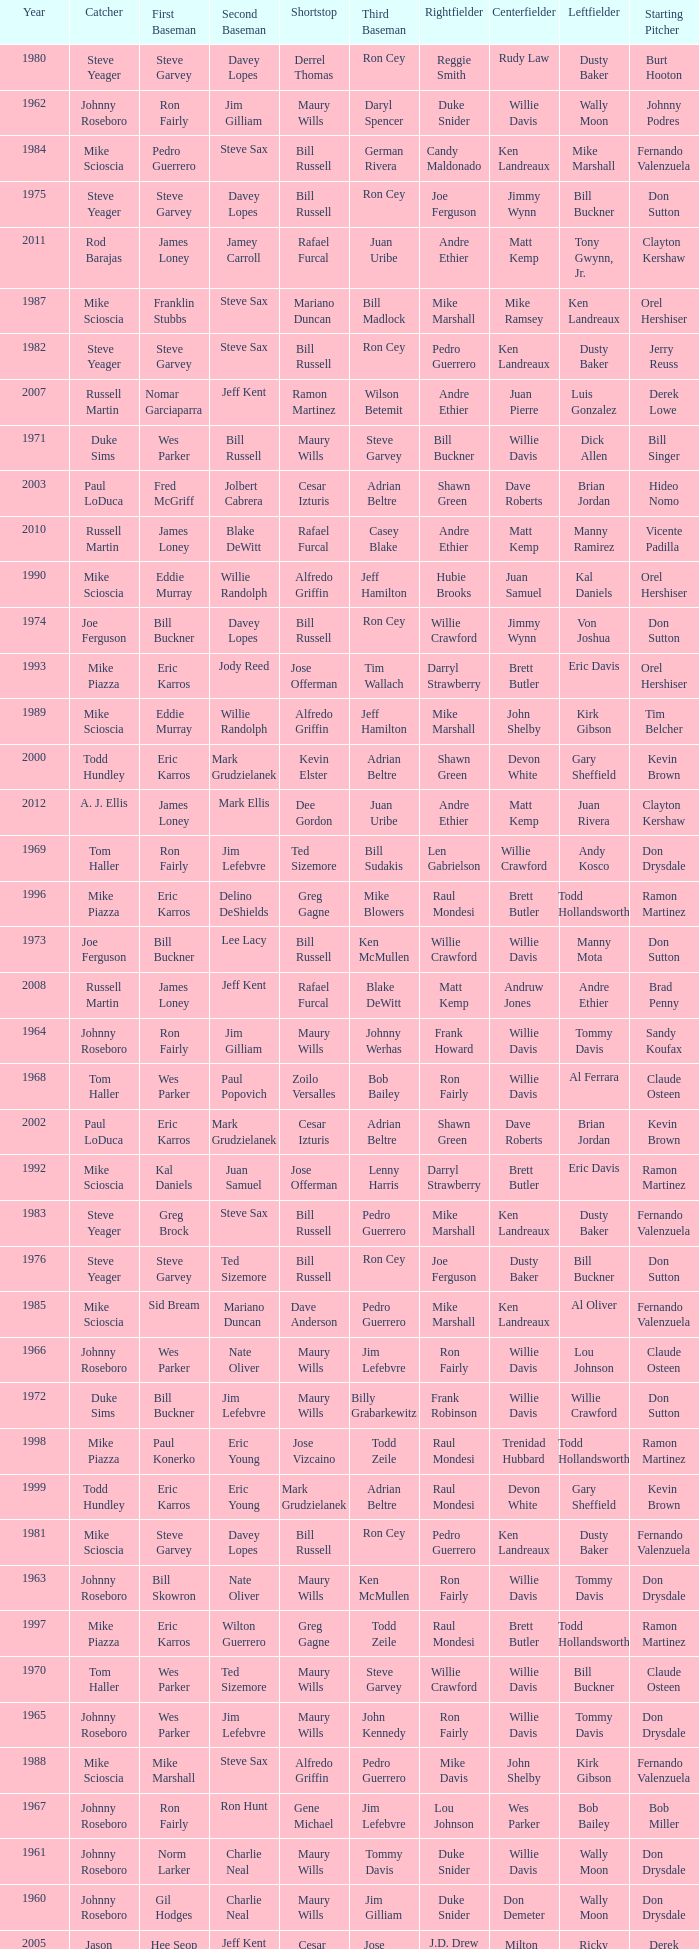Parse the full table. {'header': ['Year', 'Catcher', 'First Baseman', 'Second Baseman', 'Shortstop', 'Third Baseman', 'Rightfielder', 'Centerfielder', 'Leftfielder', 'Starting Pitcher'], 'rows': [['1980', 'Steve Yeager', 'Steve Garvey', 'Davey Lopes', 'Derrel Thomas', 'Ron Cey', 'Reggie Smith', 'Rudy Law', 'Dusty Baker', 'Burt Hooton'], ['1962', 'Johnny Roseboro', 'Ron Fairly', 'Jim Gilliam', 'Maury Wills', 'Daryl Spencer', 'Duke Snider', 'Willie Davis', 'Wally Moon', 'Johnny Podres'], ['1984', 'Mike Scioscia', 'Pedro Guerrero', 'Steve Sax', 'Bill Russell', 'German Rivera', 'Candy Maldonado', 'Ken Landreaux', 'Mike Marshall', 'Fernando Valenzuela'], ['1975', 'Steve Yeager', 'Steve Garvey', 'Davey Lopes', 'Bill Russell', 'Ron Cey', 'Joe Ferguson', 'Jimmy Wynn', 'Bill Buckner', 'Don Sutton'], ['2011', 'Rod Barajas', 'James Loney', 'Jamey Carroll', 'Rafael Furcal', 'Juan Uribe', 'Andre Ethier', 'Matt Kemp', 'Tony Gwynn, Jr.', 'Clayton Kershaw'], ['1987', 'Mike Scioscia', 'Franklin Stubbs', 'Steve Sax', 'Mariano Duncan', 'Bill Madlock', 'Mike Marshall', 'Mike Ramsey', 'Ken Landreaux', 'Orel Hershiser'], ['1982', 'Steve Yeager', 'Steve Garvey', 'Steve Sax', 'Bill Russell', 'Ron Cey', 'Pedro Guerrero', 'Ken Landreaux', 'Dusty Baker', 'Jerry Reuss'], ['2007', 'Russell Martin', 'Nomar Garciaparra', 'Jeff Kent', 'Ramon Martinez', 'Wilson Betemit', 'Andre Ethier', 'Juan Pierre', 'Luis Gonzalez', 'Derek Lowe'], ['1971', 'Duke Sims', 'Wes Parker', 'Bill Russell', 'Maury Wills', 'Steve Garvey', 'Bill Buckner', 'Willie Davis', 'Dick Allen', 'Bill Singer'], ['2003', 'Paul LoDuca', 'Fred McGriff', 'Jolbert Cabrera', 'Cesar Izturis', 'Adrian Beltre', 'Shawn Green', 'Dave Roberts', 'Brian Jordan', 'Hideo Nomo'], ['2010', 'Russell Martin', 'James Loney', 'Blake DeWitt', 'Rafael Furcal', 'Casey Blake', 'Andre Ethier', 'Matt Kemp', 'Manny Ramirez', 'Vicente Padilla'], ['1990', 'Mike Scioscia', 'Eddie Murray', 'Willie Randolph', 'Alfredo Griffin', 'Jeff Hamilton', 'Hubie Brooks', 'Juan Samuel', 'Kal Daniels', 'Orel Hershiser'], ['1974', 'Joe Ferguson', 'Bill Buckner', 'Davey Lopes', 'Bill Russell', 'Ron Cey', 'Willie Crawford', 'Jimmy Wynn', 'Von Joshua', 'Don Sutton'], ['1993', 'Mike Piazza', 'Eric Karros', 'Jody Reed', 'Jose Offerman', 'Tim Wallach', 'Darryl Strawberry', 'Brett Butler', 'Eric Davis', 'Orel Hershiser'], ['1989', 'Mike Scioscia', 'Eddie Murray', 'Willie Randolph', 'Alfredo Griffin', 'Jeff Hamilton', 'Mike Marshall', 'John Shelby', 'Kirk Gibson', 'Tim Belcher'], ['2000', 'Todd Hundley', 'Eric Karros', 'Mark Grudzielanek', 'Kevin Elster', 'Adrian Beltre', 'Shawn Green', 'Devon White', 'Gary Sheffield', 'Kevin Brown'], ['2012', 'A. J. Ellis', 'James Loney', 'Mark Ellis', 'Dee Gordon', 'Juan Uribe', 'Andre Ethier', 'Matt Kemp', 'Juan Rivera', 'Clayton Kershaw'], ['1969', 'Tom Haller', 'Ron Fairly', 'Jim Lefebvre', 'Ted Sizemore', 'Bill Sudakis', 'Len Gabrielson', 'Willie Crawford', 'Andy Kosco', 'Don Drysdale'], ['1996', 'Mike Piazza', 'Eric Karros', 'Delino DeShields', 'Greg Gagne', 'Mike Blowers', 'Raul Mondesi', 'Brett Butler', 'Todd Hollandsworth', 'Ramon Martinez'], ['1973', 'Joe Ferguson', 'Bill Buckner', 'Lee Lacy', 'Bill Russell', 'Ken McMullen', 'Willie Crawford', 'Willie Davis', 'Manny Mota', 'Don Sutton'], ['2008', 'Russell Martin', 'James Loney', 'Jeff Kent', 'Rafael Furcal', 'Blake DeWitt', 'Matt Kemp', 'Andruw Jones', 'Andre Ethier', 'Brad Penny'], ['1964', 'Johnny Roseboro', 'Ron Fairly', 'Jim Gilliam', 'Maury Wills', 'Johnny Werhas', 'Frank Howard', 'Willie Davis', 'Tommy Davis', 'Sandy Koufax'], ['1968', 'Tom Haller', 'Wes Parker', 'Paul Popovich', 'Zoilo Versalles', 'Bob Bailey', 'Ron Fairly', 'Willie Davis', 'Al Ferrara', 'Claude Osteen'], ['2002', 'Paul LoDuca', 'Eric Karros', 'Mark Grudzielanek', 'Cesar Izturis', 'Adrian Beltre', 'Shawn Green', 'Dave Roberts', 'Brian Jordan', 'Kevin Brown'], ['1992', 'Mike Scioscia', 'Kal Daniels', 'Juan Samuel', 'Jose Offerman', 'Lenny Harris', 'Darryl Strawberry', 'Brett Butler', 'Eric Davis', 'Ramon Martinez'], ['1983', 'Steve Yeager', 'Greg Brock', 'Steve Sax', 'Bill Russell', 'Pedro Guerrero', 'Mike Marshall', 'Ken Landreaux', 'Dusty Baker', 'Fernando Valenzuela'], ['1976', 'Steve Yeager', 'Steve Garvey', 'Ted Sizemore', 'Bill Russell', 'Ron Cey', 'Joe Ferguson', 'Dusty Baker', 'Bill Buckner', 'Don Sutton'], ['1985', 'Mike Scioscia', 'Sid Bream', 'Mariano Duncan', 'Dave Anderson', 'Pedro Guerrero', 'Mike Marshall', 'Ken Landreaux', 'Al Oliver', 'Fernando Valenzuela'], ['1966', 'Johnny Roseboro', 'Wes Parker', 'Nate Oliver', 'Maury Wills', 'Jim Lefebvre', 'Ron Fairly', 'Willie Davis', 'Lou Johnson', 'Claude Osteen'], ['1972', 'Duke Sims', 'Bill Buckner', 'Jim Lefebvre', 'Maury Wills', 'Billy Grabarkewitz', 'Frank Robinson', 'Willie Davis', 'Willie Crawford', 'Don Sutton'], ['1998', 'Mike Piazza', 'Paul Konerko', 'Eric Young', 'Jose Vizcaino', 'Todd Zeile', 'Raul Mondesi', 'Trenidad Hubbard', 'Todd Hollandsworth', 'Ramon Martinez'], ['1999', 'Todd Hundley', 'Eric Karros', 'Eric Young', 'Mark Grudzielanek', 'Adrian Beltre', 'Raul Mondesi', 'Devon White', 'Gary Sheffield', 'Kevin Brown'], ['1981', 'Mike Scioscia', 'Steve Garvey', 'Davey Lopes', 'Bill Russell', 'Ron Cey', 'Pedro Guerrero', 'Ken Landreaux', 'Dusty Baker', 'Fernando Valenzuela'], ['1963', 'Johnny Roseboro', 'Bill Skowron', 'Nate Oliver', 'Maury Wills', 'Ken McMullen', 'Ron Fairly', 'Willie Davis', 'Tommy Davis', 'Don Drysdale'], ['1997', 'Mike Piazza', 'Eric Karros', 'Wilton Guerrero', 'Greg Gagne', 'Todd Zeile', 'Raul Mondesi', 'Brett Butler', 'Todd Hollandsworth', 'Ramon Martinez'], ['1970', 'Tom Haller', 'Wes Parker', 'Ted Sizemore', 'Maury Wills', 'Steve Garvey', 'Willie Crawford', 'Willie Davis', 'Bill Buckner', 'Claude Osteen'], ['1965', 'Johnny Roseboro', 'Wes Parker', 'Jim Lefebvre', 'Maury Wills', 'John Kennedy', 'Ron Fairly', 'Willie Davis', 'Tommy Davis', 'Don Drysdale'], ['1988', 'Mike Scioscia', 'Mike Marshall', 'Steve Sax', 'Alfredo Griffin', 'Pedro Guerrero', 'Mike Davis', 'John Shelby', 'Kirk Gibson', 'Fernando Valenzuela'], ['1967', 'Johnny Roseboro', 'Ron Fairly', 'Ron Hunt', 'Gene Michael', 'Jim Lefebvre', 'Lou Johnson', 'Wes Parker', 'Bob Bailey', 'Bob Miller'], ['1961', 'Johnny Roseboro', 'Norm Larker', 'Charlie Neal', 'Maury Wills', 'Tommy Davis', 'Duke Snider', 'Willie Davis', 'Wally Moon', 'Don Drysdale'], ['1960', 'Johnny Roseboro', 'Gil Hodges', 'Charlie Neal', 'Maury Wills', 'Jim Gilliam', 'Duke Snider', 'Don Demeter', 'Wally Moon', 'Don Drysdale'], ['2005', 'Jason Phillips', 'Hee Seop Choi', 'Jeff Kent', 'Cesar Izturis', 'Jose Valentin', 'J.D. Drew', 'Milton Bradley', 'Ricky Ledee', 'Derek Lowe'], ['2013', 'A. J. Ellis', 'Adrian Gonzalez', 'Mark Ellis', 'Justin Sellers', 'Luis Cruz', 'Andre Ethier', 'Matt Kemp', 'Carl Crawford', 'Clayton Kershaw'], ['1978', 'Steve Yeager', 'Steve Garvey', 'Davey Lopes', 'Bill Russell', 'Ron Cey', 'Reggie Smith', 'Rick Monday', 'Dusty Baker', 'Don Sutton'], ['2001', 'Chad Kreuter', 'Eric Karros', 'Mark Grudzielanek', 'Cesar Izturis', 'Chris Donnels', 'Shawn Green', 'Tom Goodwin', 'Gary Sheffield', 'Chan Ho Park'], ['2009', 'Russell Martin', 'James Loney', 'Orlando Hudson', 'Rafael Furcal', 'Casey Blake', 'Andre Ethier', 'Matt Kemp', 'Manny Ramirez', 'Hiroki Kuroda'], ['2006', 'Sandy Alomar Jr.', 'Olmedo Saenz', 'Jeff Kent', 'Rafael Furcal', 'Bill Mueller', 'J.D. Drew', 'Jason Repko', 'Jose Cruz Jr.', 'Derek Lowe'], ['1995', 'Mike Piazza', 'Eric Karros', 'Delino DeShields', 'Jose Offerman', 'Dave Hansen', 'Henry Rodriguez', 'Raul Mondesi', 'Billy Ashley', 'Ramon Martinez'], ['1994', 'Mike Piazza', 'Eric Karros', 'Delino DeShields', 'Jose Offerman', 'Tim Wallach', 'Raul Mondesi', 'Brett Butler', 'Henry Rodriguez', 'Orel Hershiser'], ['1959', 'Johnny Roseboro', 'Gil Hodges', 'Charlie Neal', 'Don Zimmer', 'Jim Baxes', 'Ron Fairly', 'Duke Snider', 'Wally Moon', 'Don Drysdale'], ['2004', 'Paul LoDuca', 'Shawn Green', 'Alex Cora', 'Cesar Izturis', 'Adrian Beltre', 'Juan Encarnacion', 'Milton Bradley', 'Dave Roberts', 'Hideo Nomo'], ['1979', 'Steve Yeager', 'Steve Garvey', 'Davey Lopes', 'Bill Russell', 'Ron Cey', 'Reggie Smith', 'Rick Monday', 'Dusty Baker', 'Burt Hooton'], ['1977', 'Steve Yeager', 'Steve Garvey', 'Davey Lopes', 'Bill Russell', 'Ron Cey', 'Reggie Smith', 'Rick Monday', 'Dusty Baker', 'Don Sutton'], ['1986', 'Mike Scioscia', 'Greg Brock', 'Steve Sax', 'Mariano Duncan', 'Bill Madlock', 'Mike Marshall', 'Ken Landreaux', 'Franklin Stubbs', 'Fernando Valenzuela'], ['1991', 'Mike Scioscia', 'Eddie Murray', 'Juan Samuel', 'Alfredo Griffin', 'Lenny Harris', 'Darryl Strawberry', 'Brett Butler', 'Kal Daniels', 'Tim Belcher']]} Who was the RF when the SP was vicente padilla? Andre Ethier. 